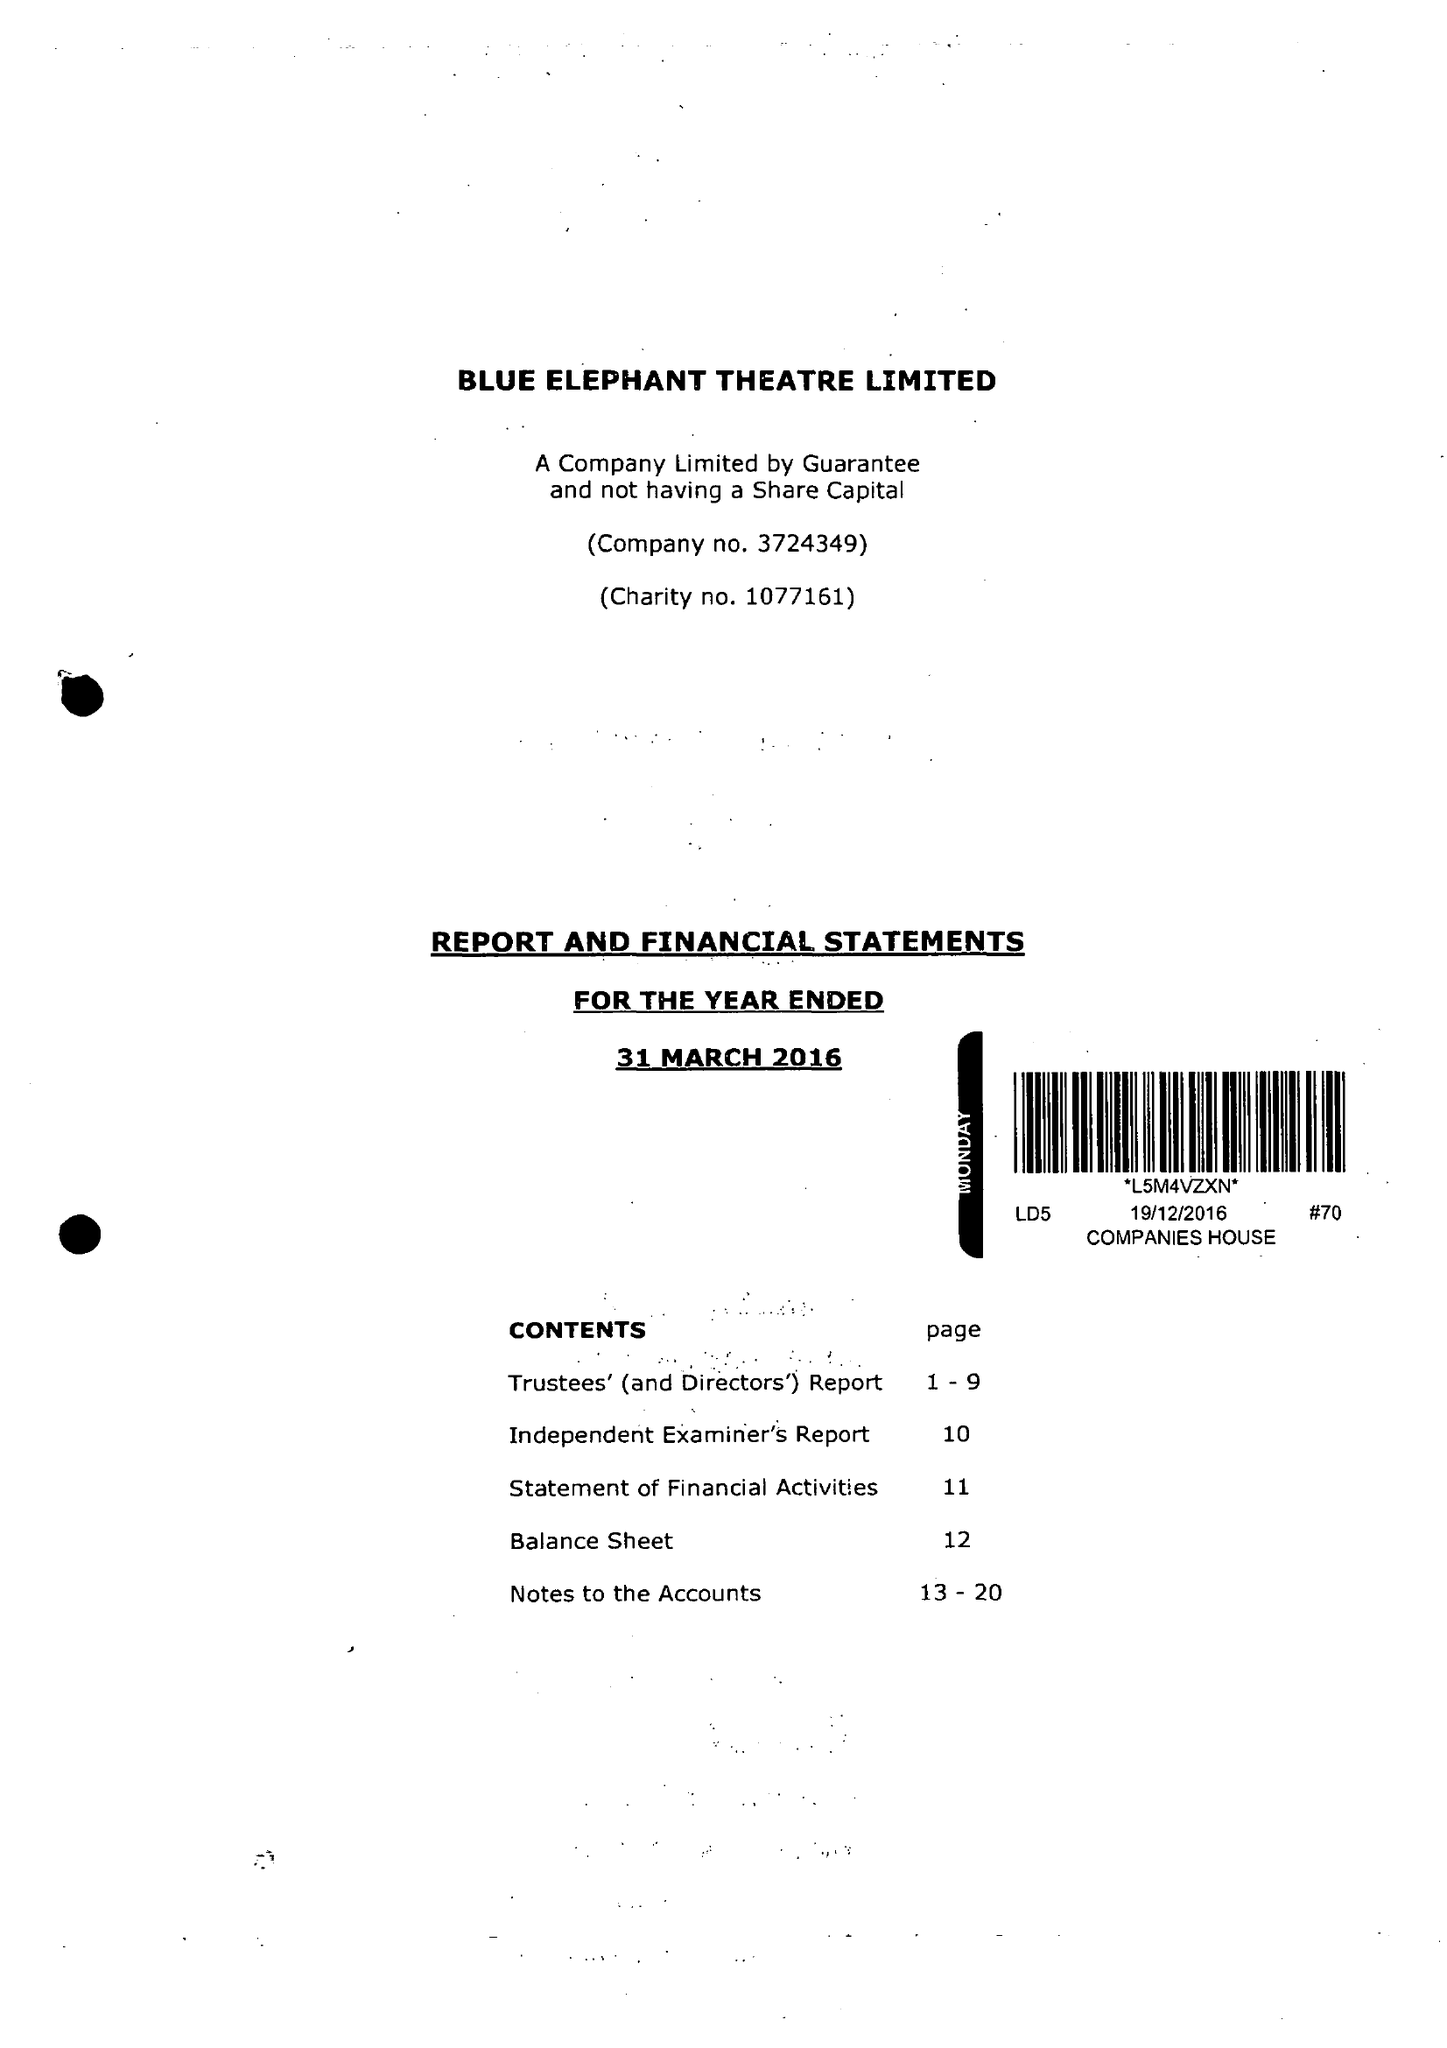What is the value for the charity_number?
Answer the question using a single word or phrase. 1077161 